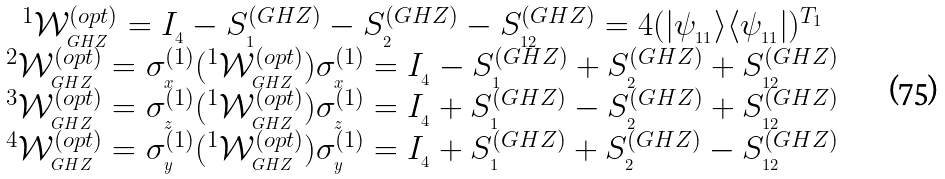Convert formula to latex. <formula><loc_0><loc_0><loc_500><loc_500>\begin{array} { c } ^ { 1 } \mathcal { W } _ { _ { G H Z } } ^ { ( o p t ) } = I _ { _ { 4 } } - S _ { _ { 1 } } ^ { ( G H Z ) } - S _ { _ { 2 } } ^ { ( G H Z ) } - S _ { _ { 1 2 } } ^ { ( G H Z ) } = 4 ( | \psi _ { _ { 1 1 } } \rangle \langle \psi _ { _ { 1 1 } } | ) ^ { T _ { 1 } } \\ ^ { 2 } \mathcal { W } _ { _ { G H Z } } ^ { ( o p t ) } = \sigma _ { _ { x } } ^ { ( 1 ) } ( ^ { 1 } \mathcal { W } _ { _ { G H Z } } ^ { ( o p t ) } ) \sigma _ { _ { x } } ^ { ( 1 ) } = I _ { _ { 4 } } - S _ { _ { 1 } } ^ { ( G H Z ) } + S _ { _ { 2 } } ^ { ( G H Z ) } + S _ { _ { 1 2 } } ^ { ( G H Z ) } \\ ^ { 3 } \mathcal { W } _ { _ { G H Z } } ^ { ( o p t ) } = \sigma _ { _ { z } } ^ { ( 1 ) } ( ^ { 1 } \mathcal { W } _ { _ { G H Z } } ^ { ( o p t ) } ) \sigma _ { _ { z } } ^ { ( 1 ) } = I _ { _ { 4 } } + S _ { _ { 1 } } ^ { ( G H Z ) } - S _ { _ { 2 } } ^ { ( G H Z ) } + S _ { _ { 1 2 } } ^ { ( G H Z ) } \\ ^ { 4 } \mathcal { W } _ { _ { G H Z } } ^ { ( o p t ) } = \sigma _ { _ { y } } ^ { ( 1 ) } ( ^ { 1 } \mathcal { W } _ { _ { G H Z } } ^ { ( o p t ) } ) \sigma _ { _ { y } } ^ { ( 1 ) } = I _ { _ { 4 } } + S _ { _ { 1 } } ^ { ( G H Z ) } + S _ { _ { 2 } } ^ { ( G H Z ) } - S _ { _ { 1 2 } } ^ { ( G H Z ) } \\ \end{array}</formula> 